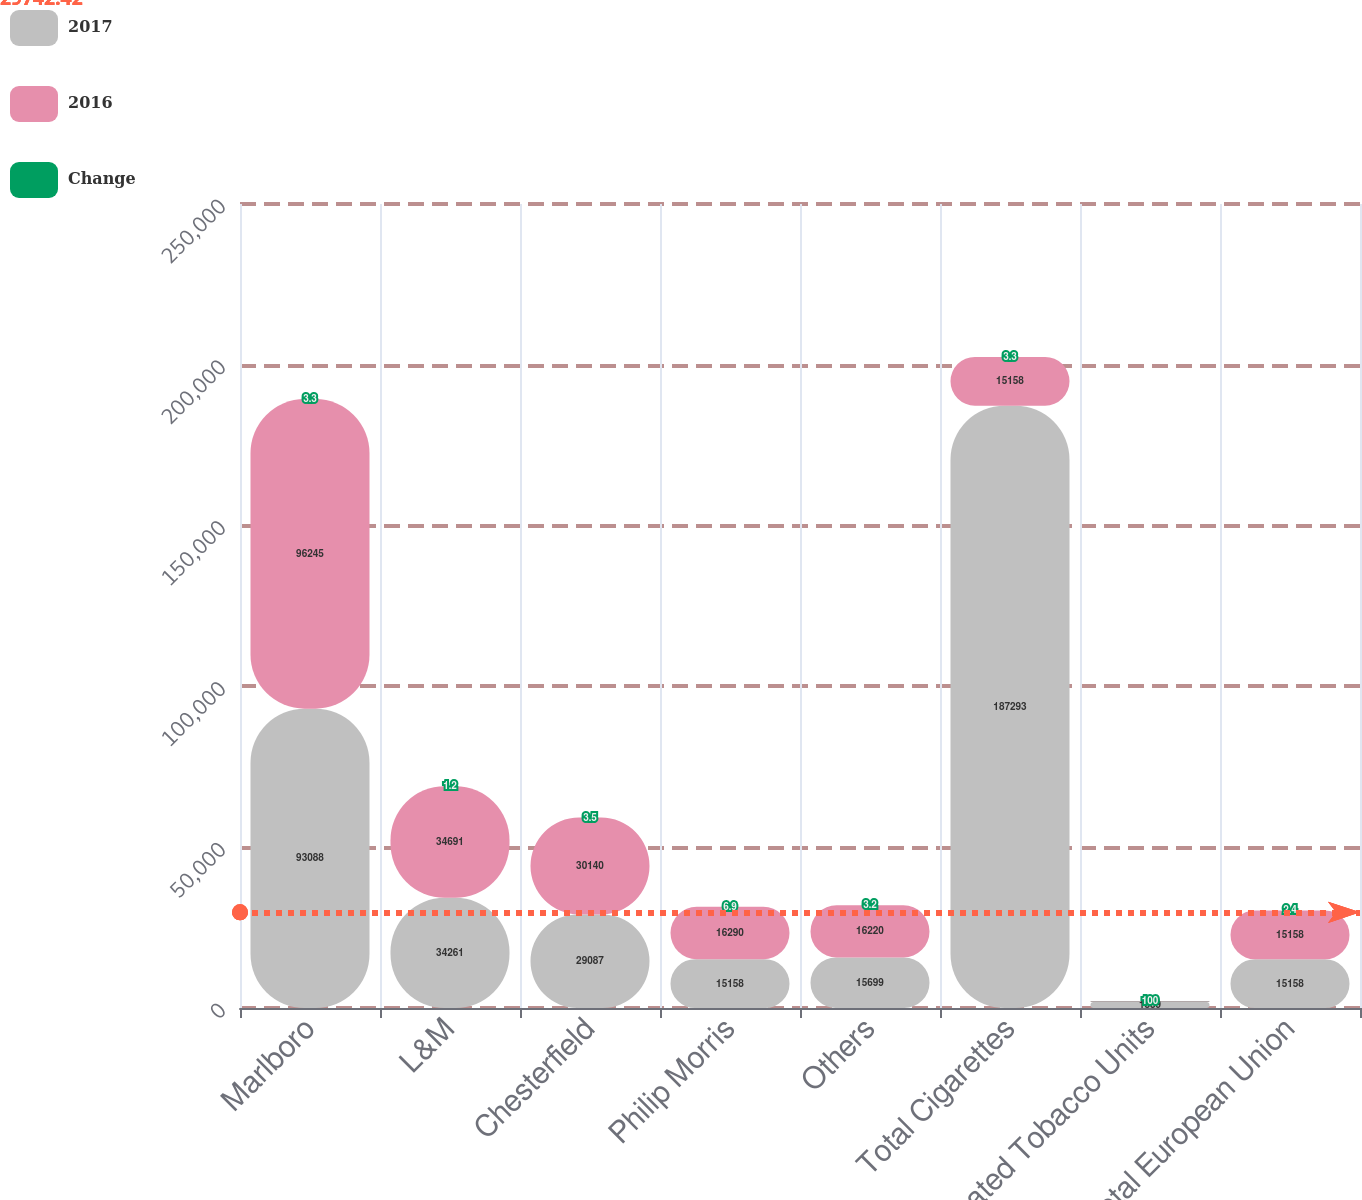<chart> <loc_0><loc_0><loc_500><loc_500><stacked_bar_chart><ecel><fcel>Marlboro<fcel>L&M<fcel>Chesterfield<fcel>Philip Morris<fcel>Others<fcel>Total Cigarettes<fcel>Heated Tobacco Units<fcel>Total European Union<nl><fcel>2017<fcel>93088<fcel>34261<fcel>29087<fcel>15158<fcel>15699<fcel>187293<fcel>1889<fcel>15158<nl><fcel>2016<fcel>96245<fcel>34691<fcel>30140<fcel>16290<fcel>16220<fcel>15158<fcel>224<fcel>15158<nl><fcel>Change<fcel>3.3<fcel>1.2<fcel>3.5<fcel>6.9<fcel>3.2<fcel>3.3<fcel>100<fcel>2.4<nl></chart> 